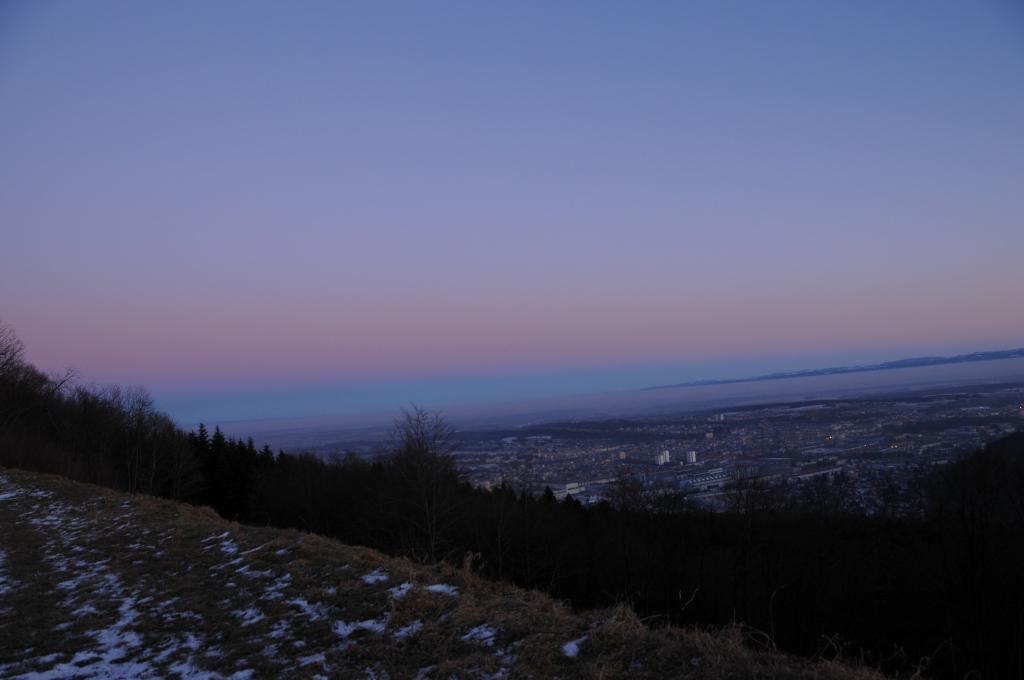Please provide a concise description of this image. This image is clicked on the mountain. At the bottom, there is ground. In the middle, there are trees and plants. In the background, there is a city. In which there are many building. And there is an ocean. 